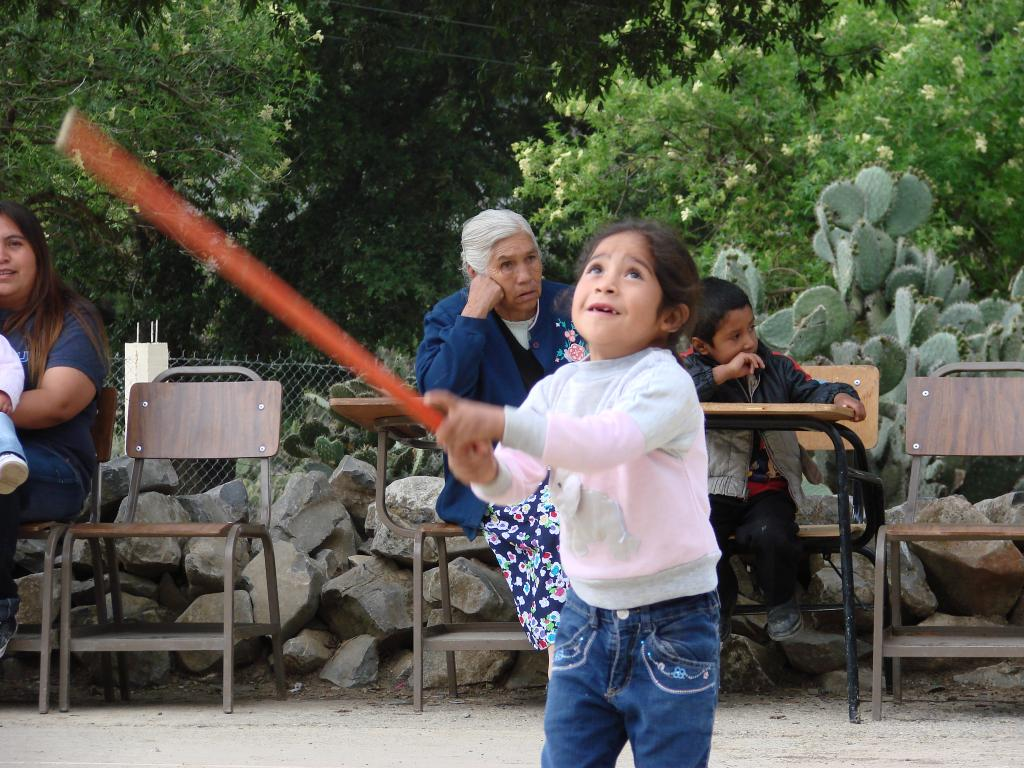What is the main subject of the image? The main subject of the image is a kid. What is the kid doing in the image? The kid is playing with a stick in her hand. Can you describe the background of the image? There are people sitting on chairs in the background of the image. What is the tendency of the spark in the image? There is no spark present in the image. How does the snow affect the kid's playtime in the image? There is no snow present in the image, so it does not affect the kid's playtime. 